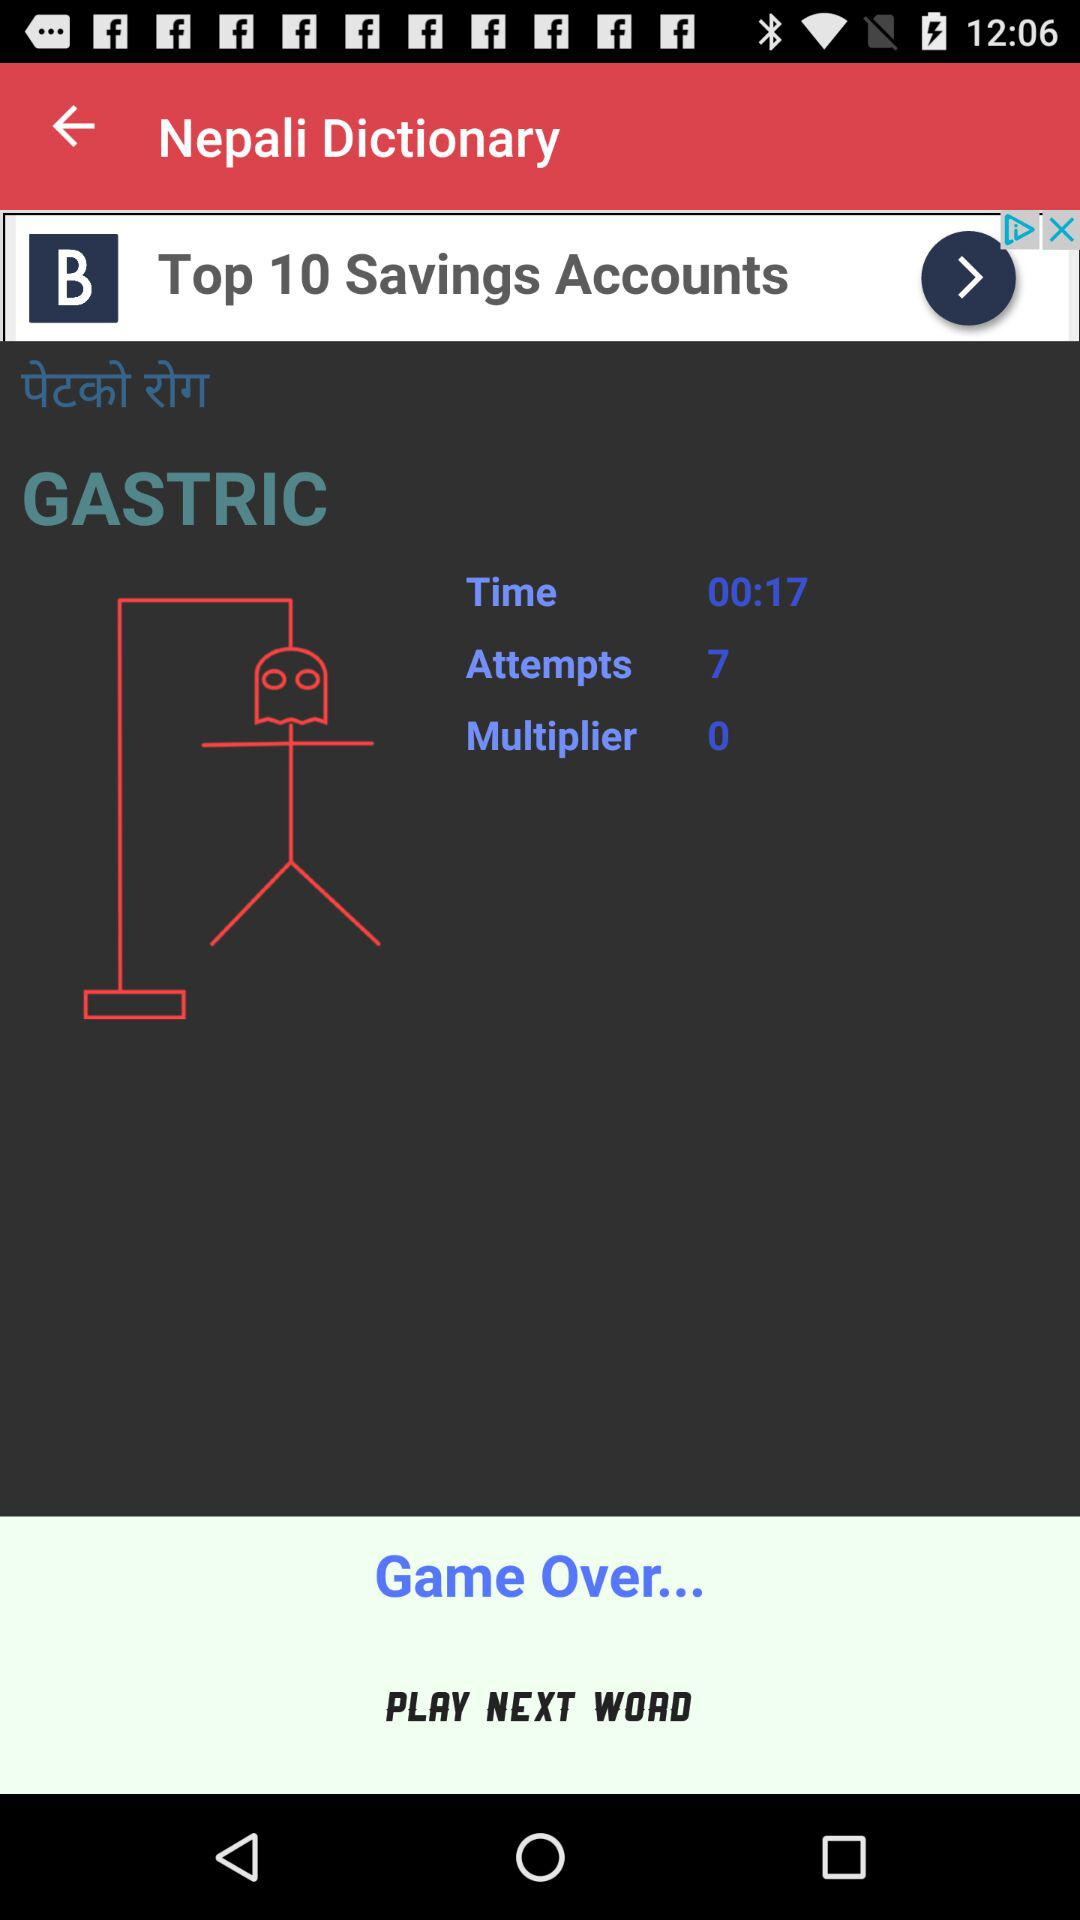How many attempts were made? The number of attempts made was 7. 